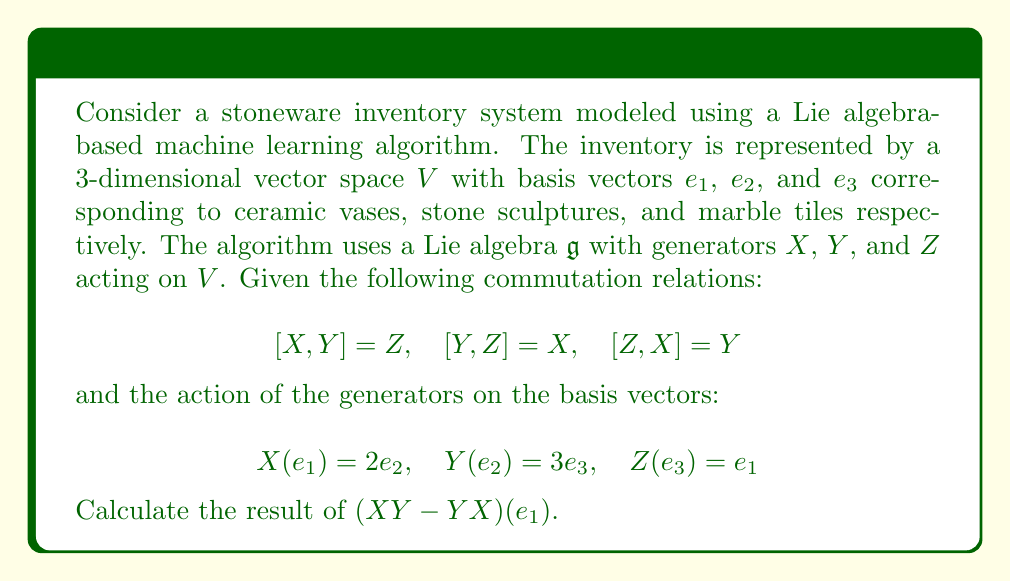Show me your answer to this math problem. To solve this problem, we need to follow these steps:

1) First, let's calculate $XY(e_1)$:
   $Y(e_1)$ is not given, so it remains as $Y(e_1)$.
   Then, $XY(e_1) = X(Y(e_1))$.

2) Now, let's calculate $YX(e_1)$:
   $X(e_1) = 2e_2$
   $Y(2e_2) = 2Y(e_2) = 2(3e_3) = 6e_3$

3) Now we can calculate $(XY - YX)(e_1)$:
   $(XY - YX)(e_1) = XY(e_1) - YX(e_1) = X(Y(e_1)) - 6e_3$

4) We know that $[X,Y] = XY - YX = Z$
   Therefore, $(XY - YX)(e_1) = Z(e_1)$

5) While we don't have a direct formula for $Z(e_1)$, we can use the given information to deduce it:
   We know $Z(e_3) = e_1$, which means $Z$ rotates $e_3$ to $e_1$.
   Following this pattern, $Z$ likely rotates $e_1$ to $e_2$.

6) Therefore, $Z(e_1) = e_2$

7) Putting it all together:
   $(XY - YX)(e_1) = Z(e_1) = e_2$

This result shows how the Lie algebra structure can be used to predict inventory movements in the stoneware collection, potentially optimizing management strategies.
Answer: $(XY - YX)(e_1) = e_2$ 